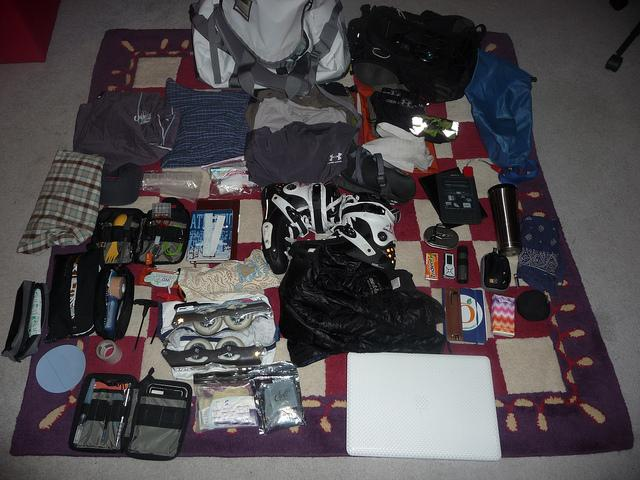Items here are laid out due to what purpose?

Choices:
A) display wealth
B) packing backpack
C) moving sale
D) manic behaviour packing backpack 